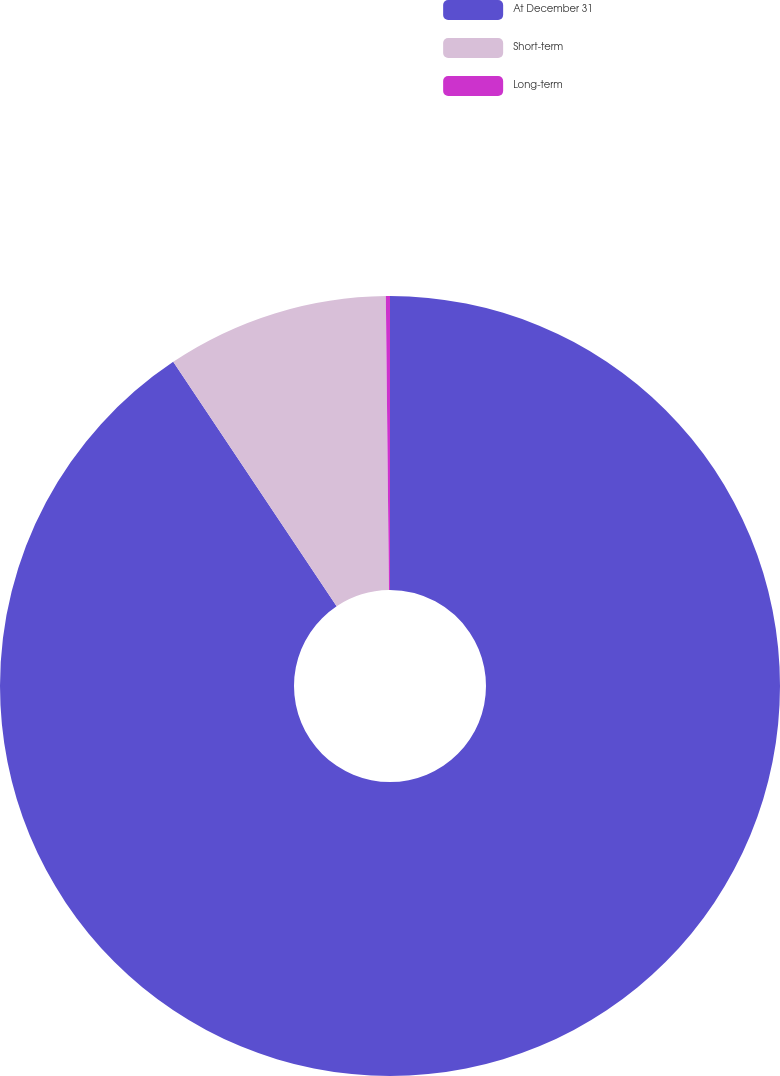Convert chart. <chart><loc_0><loc_0><loc_500><loc_500><pie_chart><fcel>At December 31<fcel>Short-term<fcel>Long-term<nl><fcel>90.62%<fcel>9.21%<fcel>0.17%<nl></chart> 